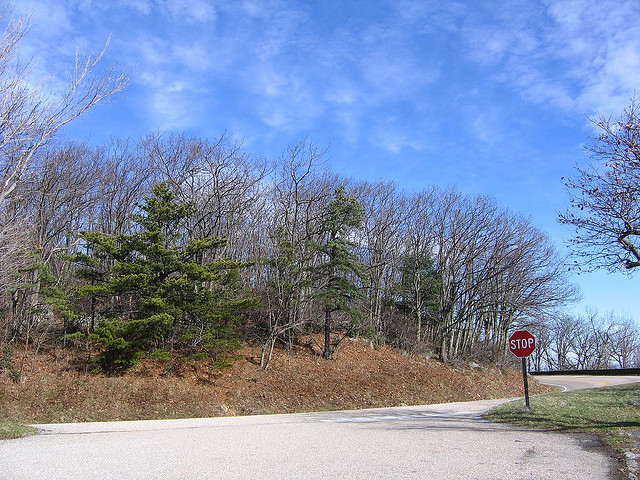What is the name of the photographic effect applied to this image? The image does not appear to have a specific photographic effect applied; it looks like a standard photograph. 